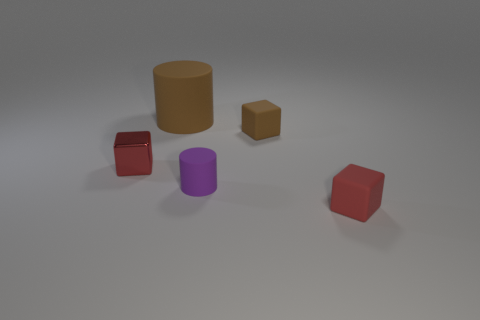Subtract all small rubber cubes. How many cubes are left? 1 Subtract all brown cylinders. How many red cubes are left? 2 Add 5 purple cylinders. How many objects exist? 10 Subtract all brown cubes. How many cubes are left? 2 Subtract all cylinders. How many objects are left? 3 Subtract all purple metallic balls. Subtract all purple cylinders. How many objects are left? 4 Add 5 brown cylinders. How many brown cylinders are left? 6 Add 2 brown matte balls. How many brown matte balls exist? 2 Subtract 0 purple balls. How many objects are left? 5 Subtract all yellow cubes. Subtract all green balls. How many cubes are left? 3 